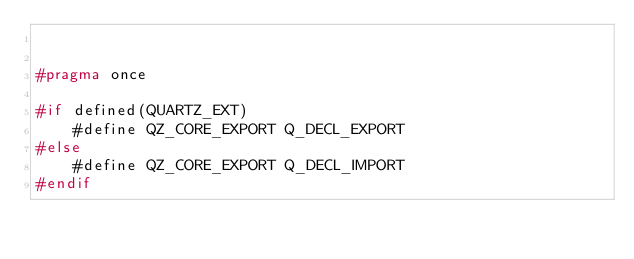<code> <loc_0><loc_0><loc_500><loc_500><_C_>

#pragma once

#if defined(QUARTZ_EXT)
    #define QZ_CORE_EXPORT Q_DECL_EXPORT
#else
    #define QZ_CORE_EXPORT Q_DECL_IMPORT
#endif
</code> 